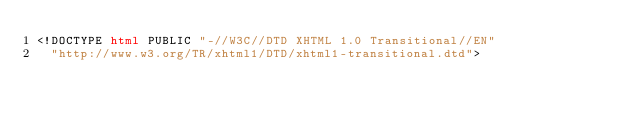Convert code to text. <code><loc_0><loc_0><loc_500><loc_500><_HTML_><!DOCTYPE html PUBLIC "-//W3C//DTD XHTML 1.0 Transitional//EN"
  "http://www.w3.org/TR/xhtml1/DTD/xhtml1-transitional.dtd">

</code> 